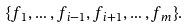Convert formula to latex. <formula><loc_0><loc_0><loc_500><loc_500>\{ f _ { 1 } , \dots , f _ { i - 1 } , f _ { i + 1 } , \dots , f _ { m } \} .</formula> 